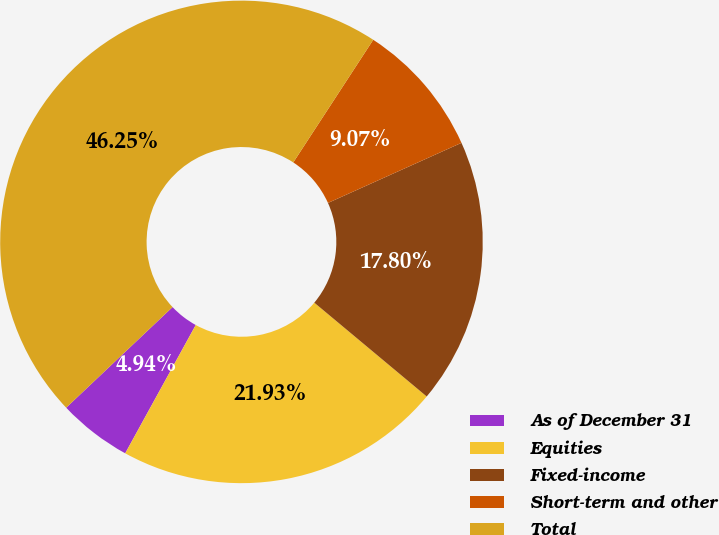<chart> <loc_0><loc_0><loc_500><loc_500><pie_chart><fcel>As of December 31<fcel>Equities<fcel>Fixed-income<fcel>Short-term and other<fcel>Total<nl><fcel>4.94%<fcel>21.93%<fcel>17.8%<fcel>9.07%<fcel>46.25%<nl></chart> 